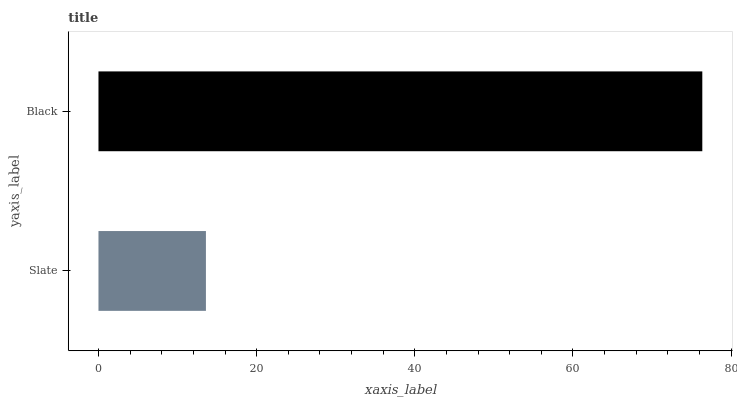Is Slate the minimum?
Answer yes or no. Yes. Is Black the maximum?
Answer yes or no. Yes. Is Black the minimum?
Answer yes or no. No. Is Black greater than Slate?
Answer yes or no. Yes. Is Slate less than Black?
Answer yes or no. Yes. Is Slate greater than Black?
Answer yes or no. No. Is Black less than Slate?
Answer yes or no. No. Is Black the high median?
Answer yes or no. Yes. Is Slate the low median?
Answer yes or no. Yes. Is Slate the high median?
Answer yes or no. No. Is Black the low median?
Answer yes or no. No. 